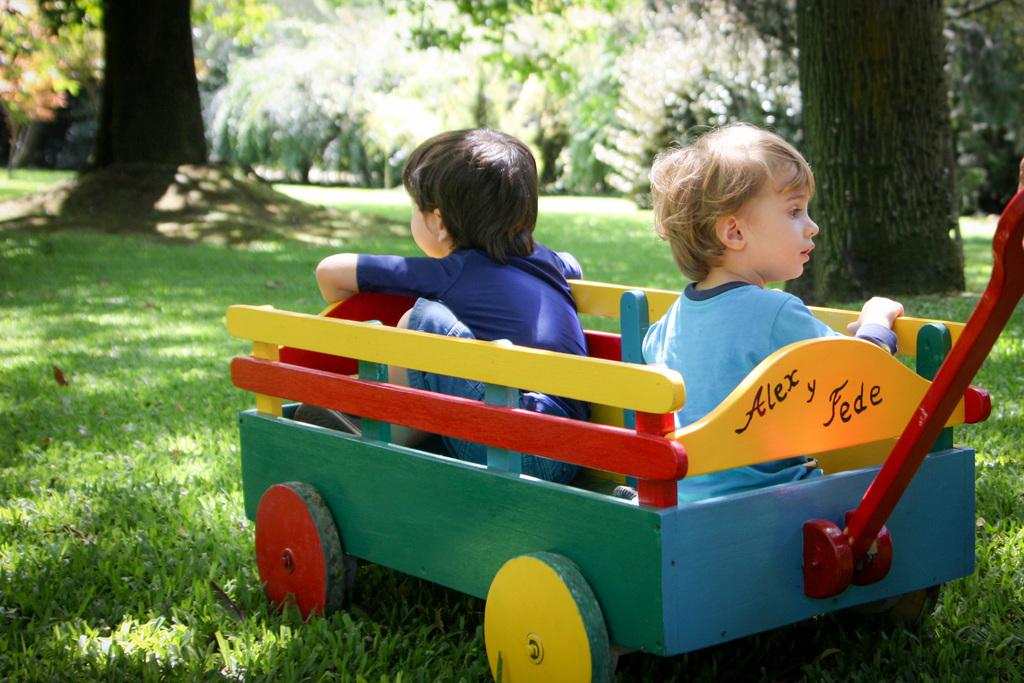What object is present in the image that can be used for transportation? There is a wooden trolley in the image that can be used for transportation. Who is using the trolley in the image? There are kids seated in the trolley in the image. What colors are present on the trolley? The trolley has green, yellow, blue, and red colors. What type of terrain is visible in the image? There is grass on the ground in the image, and trees are visible as well. What type of bubble can be seen floating around the kids in the image? There is no bubble present in the image; it only features a wooden trolley with kids seated in it, grass, and trees. 